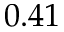<formula> <loc_0><loc_0><loc_500><loc_500>0 . 4 1</formula> 